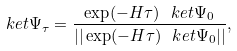Convert formula to latex. <formula><loc_0><loc_0><loc_500><loc_500>\ k e t { \Psi _ { \tau } } = \frac { \exp ( - H \tau ) \ k e t { \Psi _ { 0 } } } { | | \exp ( - H \tau ) \ k e t { \Psi _ { 0 } } | | } ,</formula> 